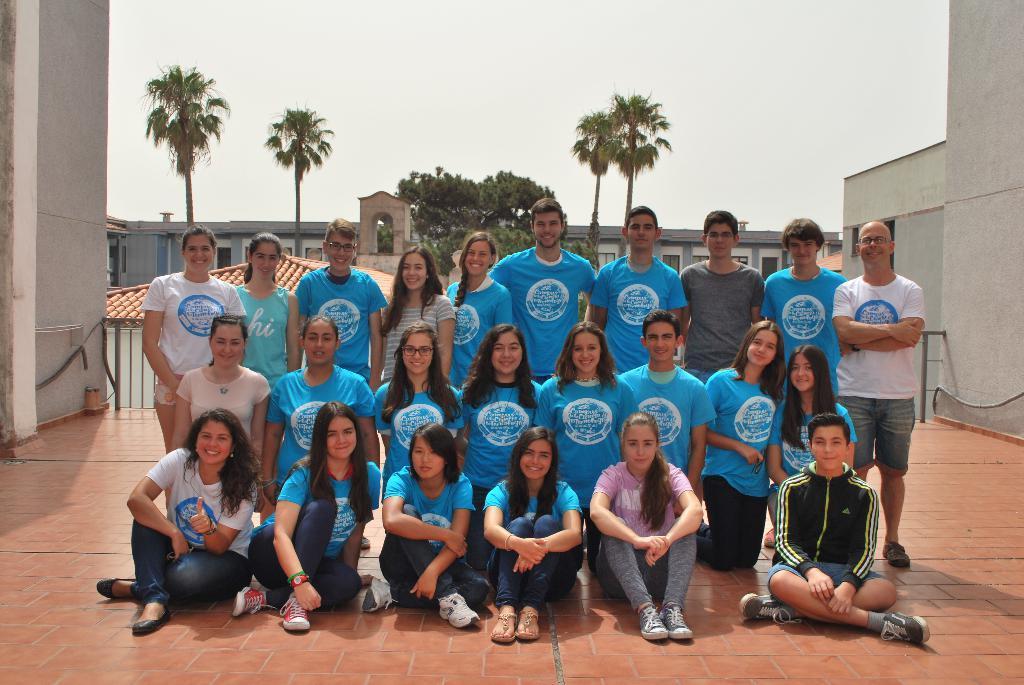Can you describe this image briefly? In this image we can see a group of people on the ground. In the background, we can see railing, some trees, buildings with windows and roofs. At the top of the image we can see the sky. 